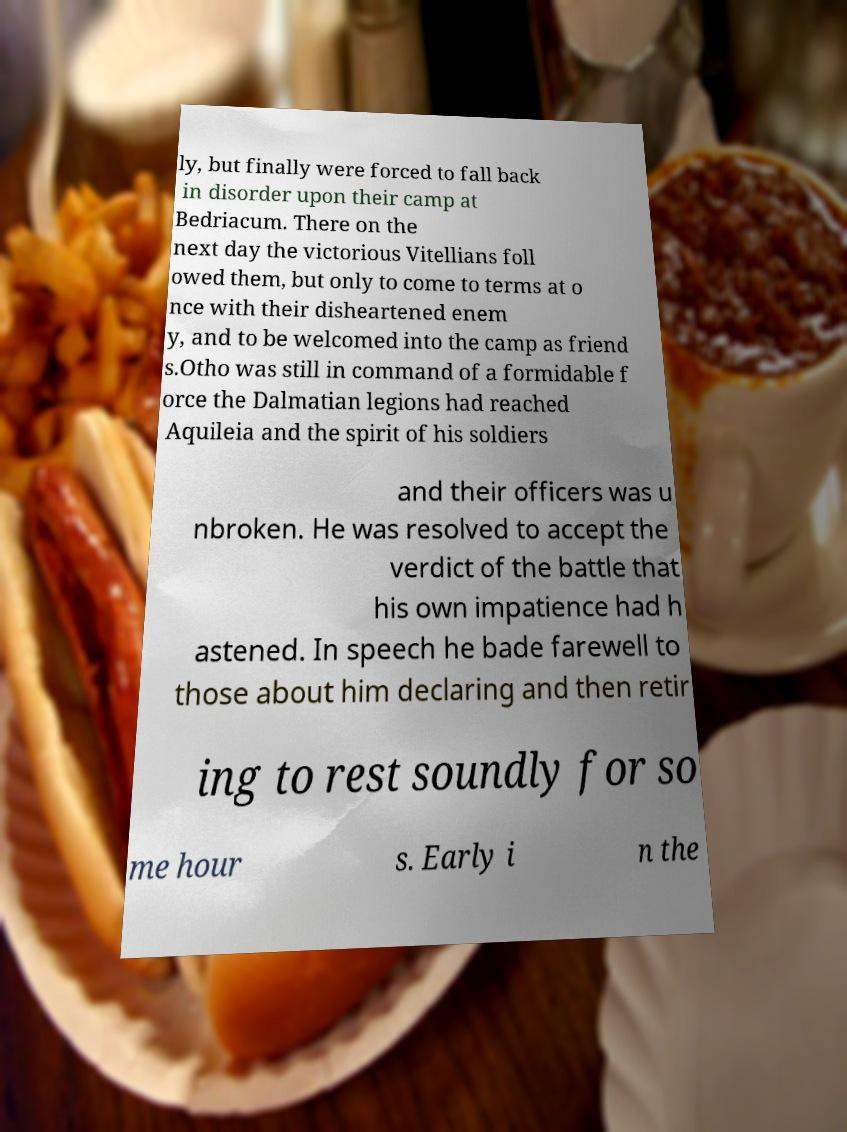Please identify and transcribe the text found in this image. ly, but finally were forced to fall back in disorder upon their camp at Bedriacum. There on the next day the victorious Vitellians foll owed them, but only to come to terms at o nce with their disheartened enem y, and to be welcomed into the camp as friend s.Otho was still in command of a formidable f orce the Dalmatian legions had reached Aquileia and the spirit of his soldiers and their officers was u nbroken. He was resolved to accept the verdict of the battle that his own impatience had h astened. In speech he bade farewell to those about him declaring and then retir ing to rest soundly for so me hour s. Early i n the 